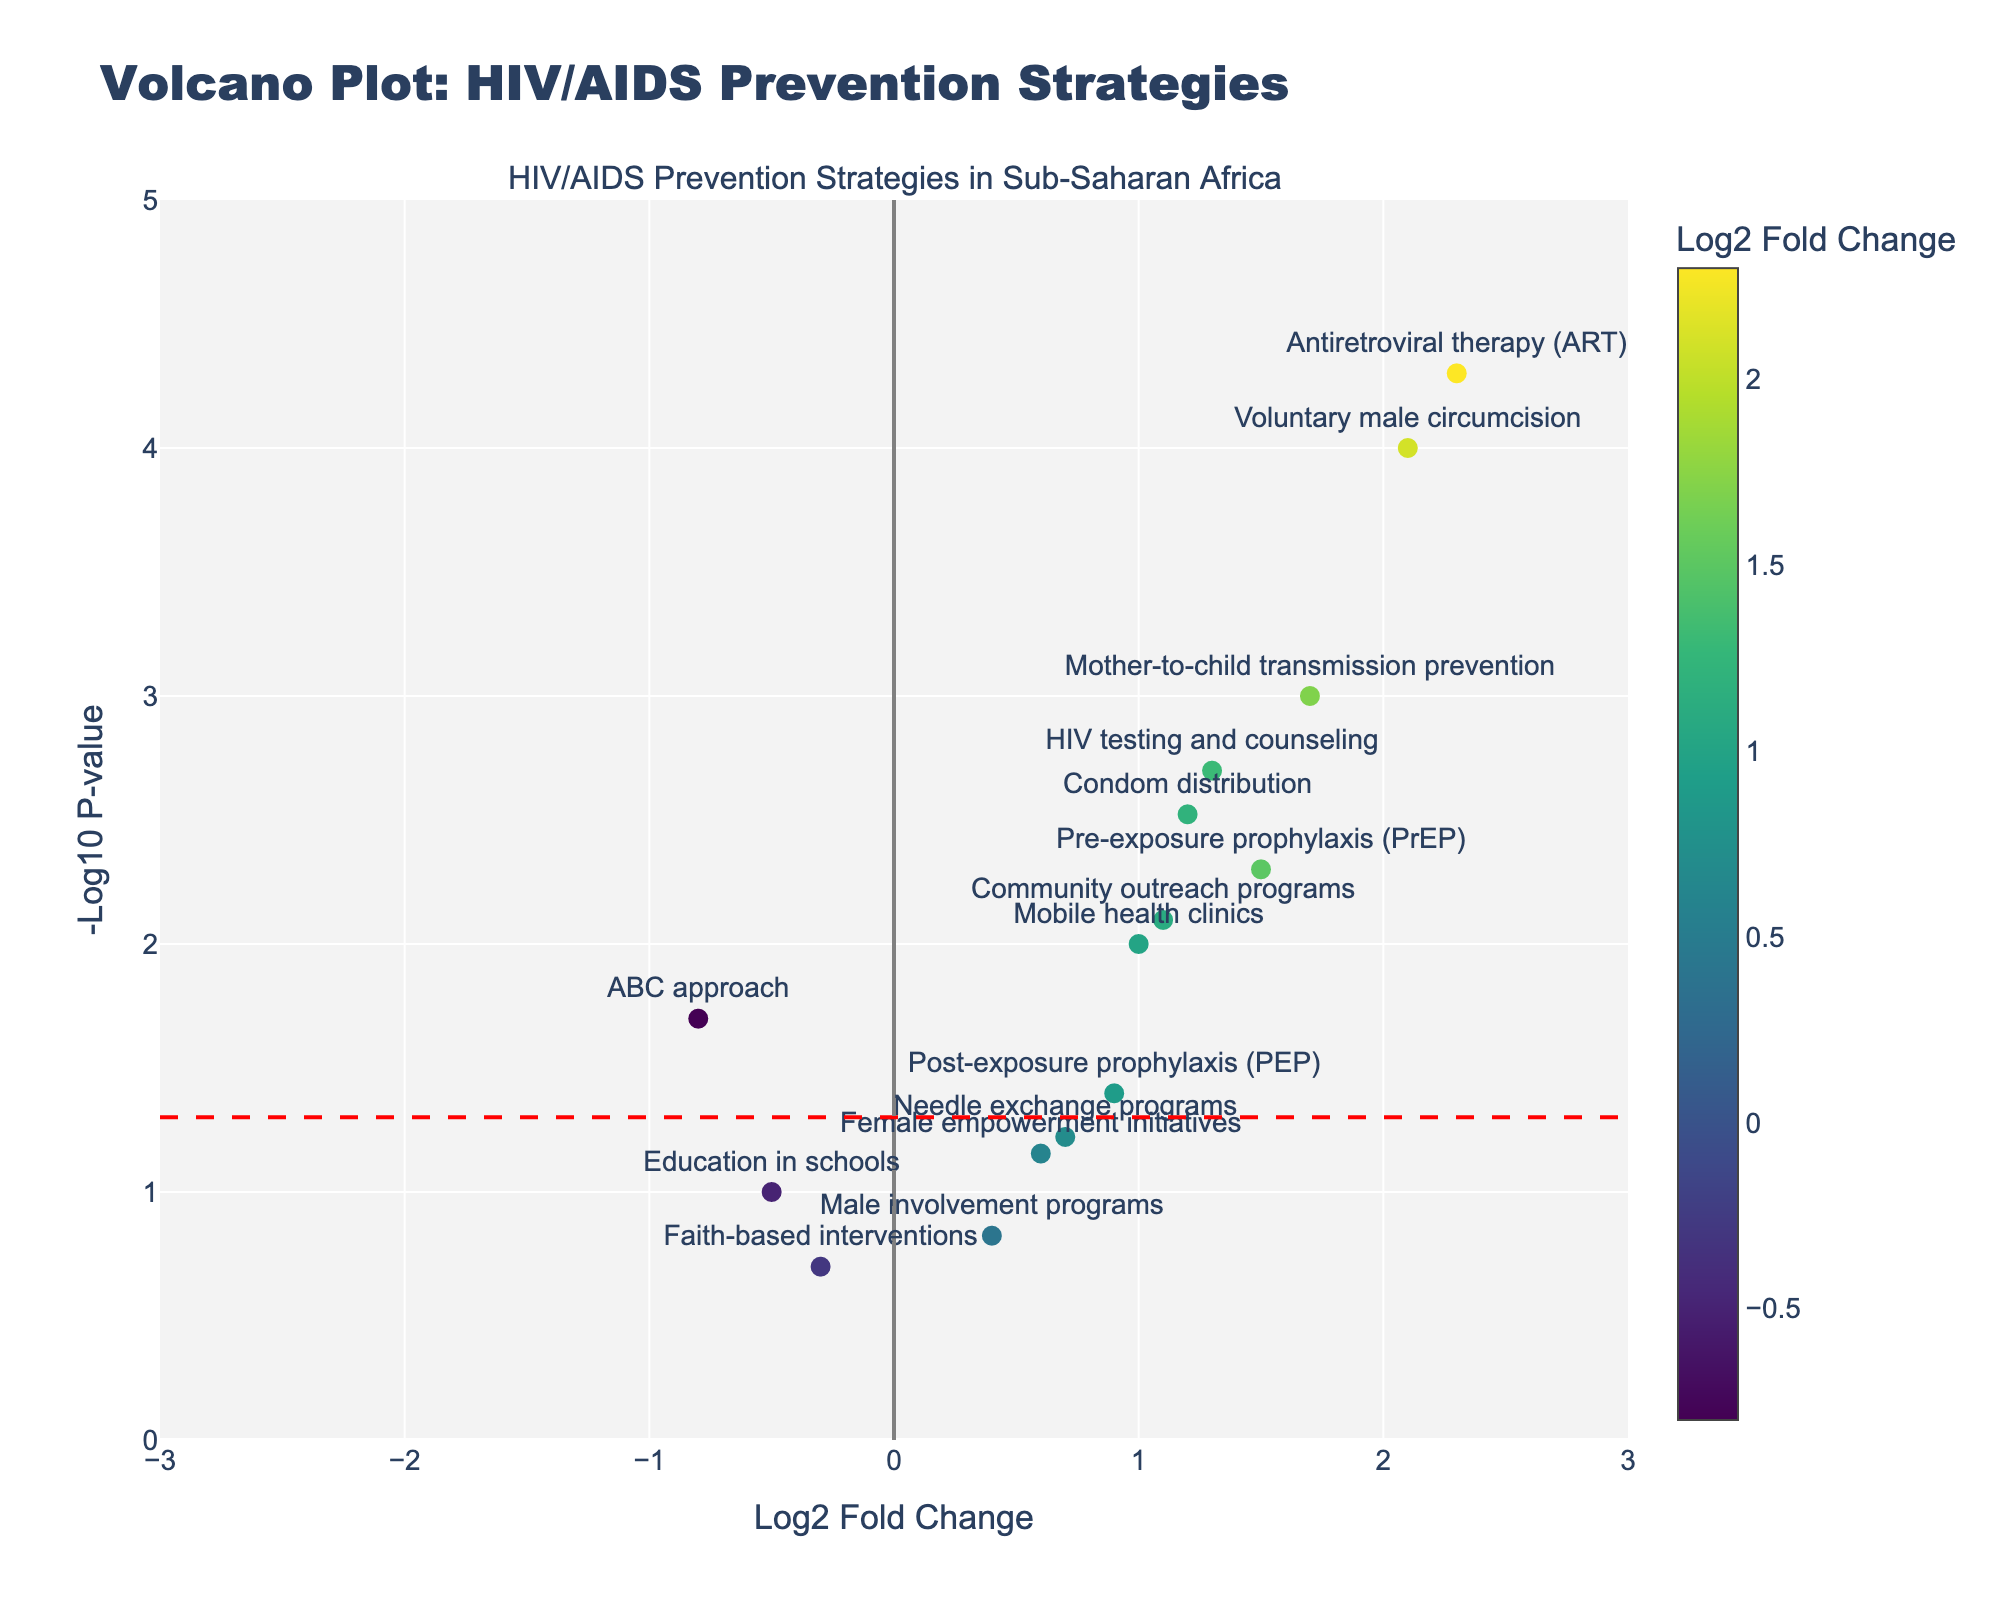What is the title of the figure? The title of the figure is often prominently displayed at the top. In this plot, it is clearly stated as "Volcano Plot: HIV/AIDS Prevention Strategies".
Answer: Volcano Plot: HIV/AIDS Prevention Strategies Which axis represents the Log2 Fold Change? The axis labels in the plot indicate which variable they represent. Here, the x-axis label reads "Log2 Fold Change".
Answer: The x-axis How many strategies have a Log2 Fold Change greater than 1? To count the number of strategies with a Log2 Fold Change greater than 1, look for dots to the right of 1 on the x-axis.
Answer: Seven strategies Which strategy has the most statistically significant result? The most statistically significant result would have the highest value on the y-axis (-Log10 P-value). Identify the dot with the highest y-value and refer to its label.
Answer: Antiretroviral therapy (ART) Is there any strategy with a negative Log2 Fold Change but a p-value less than 0.05? Look for dots to the left of zero on the x-axis that are also above the dashed horizontal line representing -Log10(0.05).
Answer: ABC approach Which strategy has the smallest Log2 Fold Change and what is its p-value? Identify the leftmost dot on the x-axis and then look at its corresponding value on the y-axis to determine the p-value.
Answer: Faith-based interventions, 0.2 How many strategies have a p-value greater than 0.05? Count the number of dots below the horizontal dashed line representing the threshold for significance (-Log10(0.05)).
Answer: Five strategies Compare the effectiveness of Antiretroviral therapy (ART) and Needle exchange programs. Which one is more effective? Compare the x-axis positions of the dots labeled Antiretroviral therapy (ART) and Needle exchange programs. The farther to the right, the more positive the Log2 Fold Change, indicating higher effectiveness.
Answer: Antiretroviral therapy (ART) Which strategies lie close to the significance threshold line (-Log10(0.05)) on the y-axis but with positive Log2 Fold Change? Identify the dots just above the horizontal dashed line on the y-axis and to the right of zero on the x-axis. Look for the strategies associated with these dots.
Answer: Mobile health clinics and Post-exposure prophylaxis (PEP) What is the range of Log2 Fold Change values displayed in the plot? The range is the difference between the maximum and minimum values observed on the x-axis. Look at the plot bounds on the x-axis.
Answer: -0.8 to 2.3 